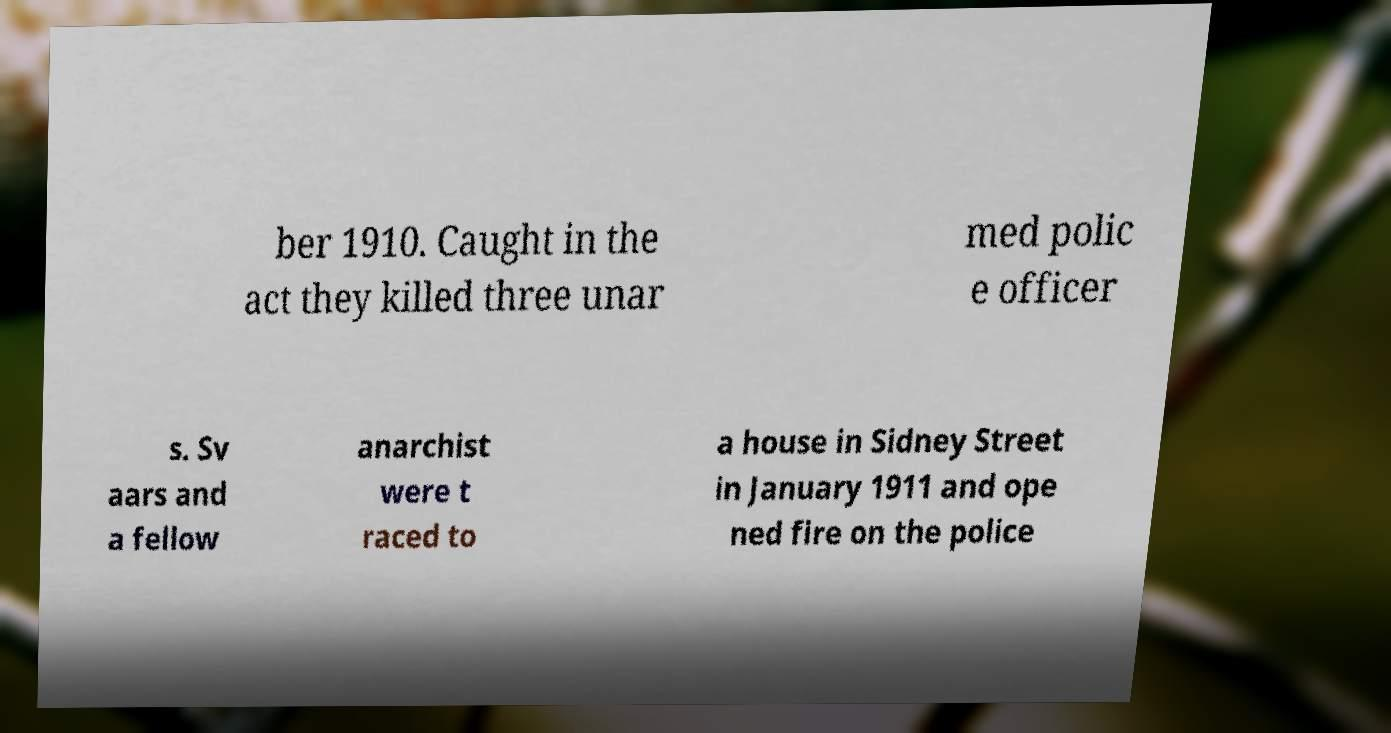Can you accurately transcribe the text from the provided image for me? ber 1910. Caught in the act they killed three unar med polic e officer s. Sv aars and a fellow anarchist were t raced to a house in Sidney Street in January 1911 and ope ned fire on the police 